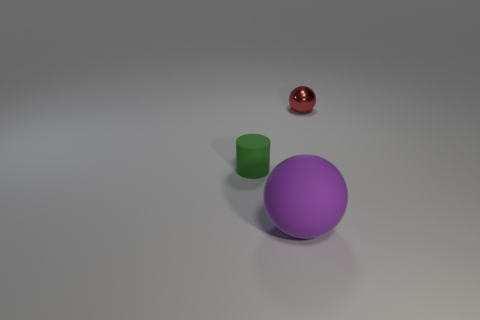How many small red metallic balls are there?
Ensure brevity in your answer.  1. How many small green objects are the same material as the cylinder?
Your answer should be very brief. 0. Are there the same number of metallic things that are on the right side of the small rubber cylinder and tiny cylinders?
Your answer should be very brief. Yes. There is a green cylinder; is it the same size as the ball that is on the right side of the purple matte sphere?
Make the answer very short. Yes. What number of other things are there of the same size as the purple matte sphere?
Keep it short and to the point. 0. What number of other things are the same color as the small metallic sphere?
Give a very brief answer. 0. Is there anything else that has the same size as the purple matte object?
Give a very brief answer. No. How many other things are the same shape as the metal thing?
Provide a short and direct response. 1. Does the purple rubber ball have the same size as the red sphere?
Offer a very short reply. No. Is there a tiny green cylinder?
Ensure brevity in your answer.  Yes. 